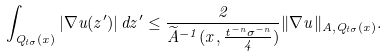<formula> <loc_0><loc_0><loc_500><loc_500>\int _ { Q _ { t \sigma } ( x ) } | \nabla u ( z ^ { \prime } ) | \, d z ^ { \prime } \leq \frac { 2 } { \widetilde { A } ^ { - 1 } ( x , \frac { t ^ { - n } \sigma ^ { - n } } { 4 } ) } \| \nabla u \| _ { A , Q _ { t \sigma } ( x ) } .</formula> 